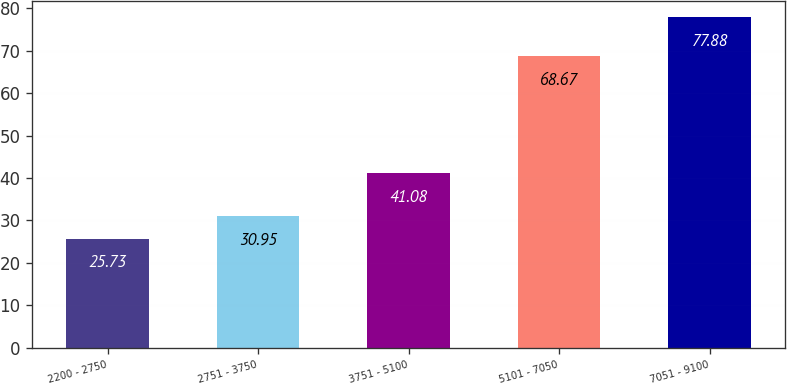<chart> <loc_0><loc_0><loc_500><loc_500><bar_chart><fcel>2200 - 2750<fcel>2751 - 3750<fcel>3751 - 5100<fcel>5101 - 7050<fcel>7051 - 9100<nl><fcel>25.73<fcel>30.95<fcel>41.08<fcel>68.67<fcel>77.88<nl></chart> 